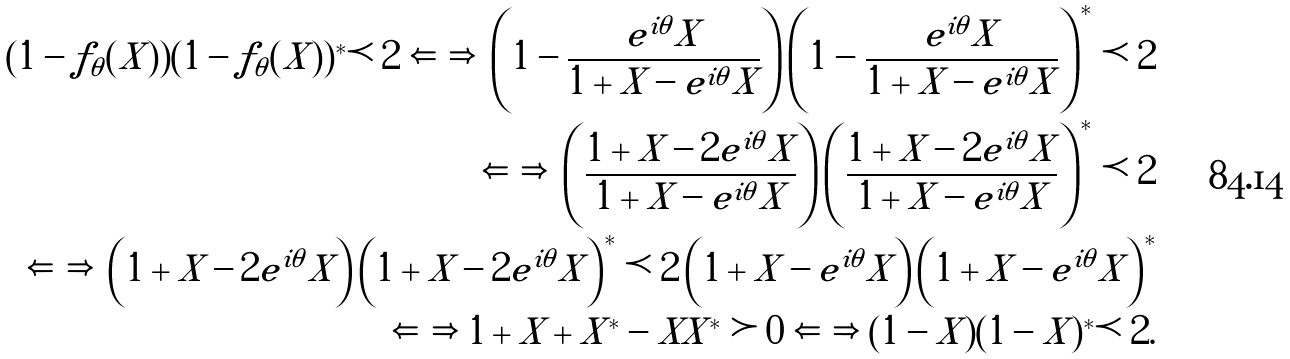<formula> <loc_0><loc_0><loc_500><loc_500>( 1 - f _ { \theta } ( X ) ) ( 1 - f _ { \theta } ( X ) ) ^ { * } \prec 2 \iff \left ( 1 - \frac { e ^ { i \theta } X } { 1 + X - e ^ { i \theta } X } \right ) \left ( 1 - \frac { e ^ { i \theta } X } { 1 + X - e ^ { i \theta } X } \right ) ^ { * } \prec 2 \\ \iff \left ( \frac { 1 + X - 2 e ^ { i \theta } X } { 1 + X - e ^ { i \theta } X } \right ) \left ( \frac { 1 + X - 2 e ^ { i \theta } X } { 1 + X - e ^ { i \theta } X } \right ) ^ { * } \prec 2 \\ \iff \left ( { 1 + X - 2 e ^ { i \theta } X } \right ) \left ( { 1 + X - 2 e ^ { i \theta } X } \right ) ^ { * } \prec 2 \left ( { 1 + X - e ^ { i \theta } X } \right ) \left ( { 1 + X - e ^ { i \theta } X } \right ) ^ { * } \\ \iff 1 + X + X ^ { * } - X X ^ { * } \succ 0 \iff ( 1 - X ) ( 1 - X ) ^ { * } \prec 2 .</formula> 